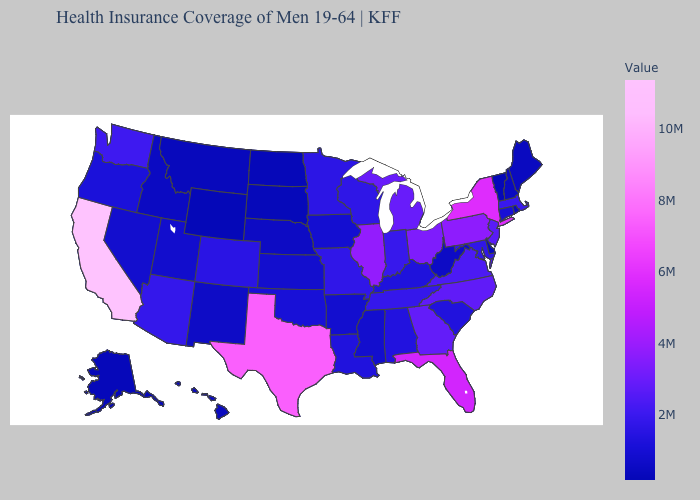Does Illinois have the highest value in the MidWest?
Short answer required. Yes. Does California have a lower value than West Virginia?
Short answer required. No. Does Maine have the highest value in the Northeast?
Concise answer only. No. Does Georgia have a higher value than Nevada?
Concise answer only. Yes. Does the map have missing data?
Short answer required. No. 